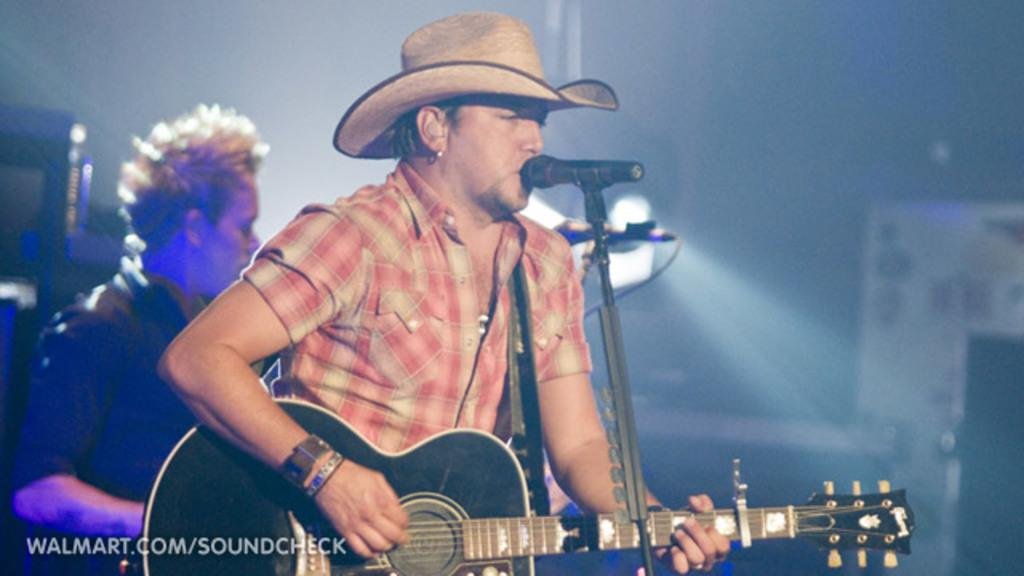What is the man in the image doing? The man is standing and playing a guitar. What is the man standing in front of? The man is standing in front of a microphone. Can you describe the man's attire? The man is wearing a hat. Is there anyone else in the image? Yes, there is another man standing behind the first man. What type of lock is being discussed by the two men in the image? There is no discussion or lock present in the image; it features a man playing a guitar and standing in front of a microphone. 